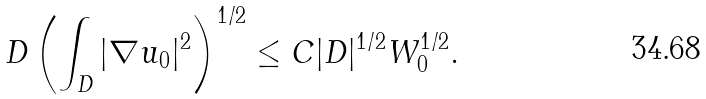Convert formula to latex. <formula><loc_0><loc_0><loc_500><loc_500>\ D \left ( \int _ { D } | \nabla u _ { 0 } | ^ { 2 } \right ) ^ { 1 / 2 } \leq C | D | ^ { 1 / 2 } W _ { 0 } ^ { 1 / 2 } .</formula> 